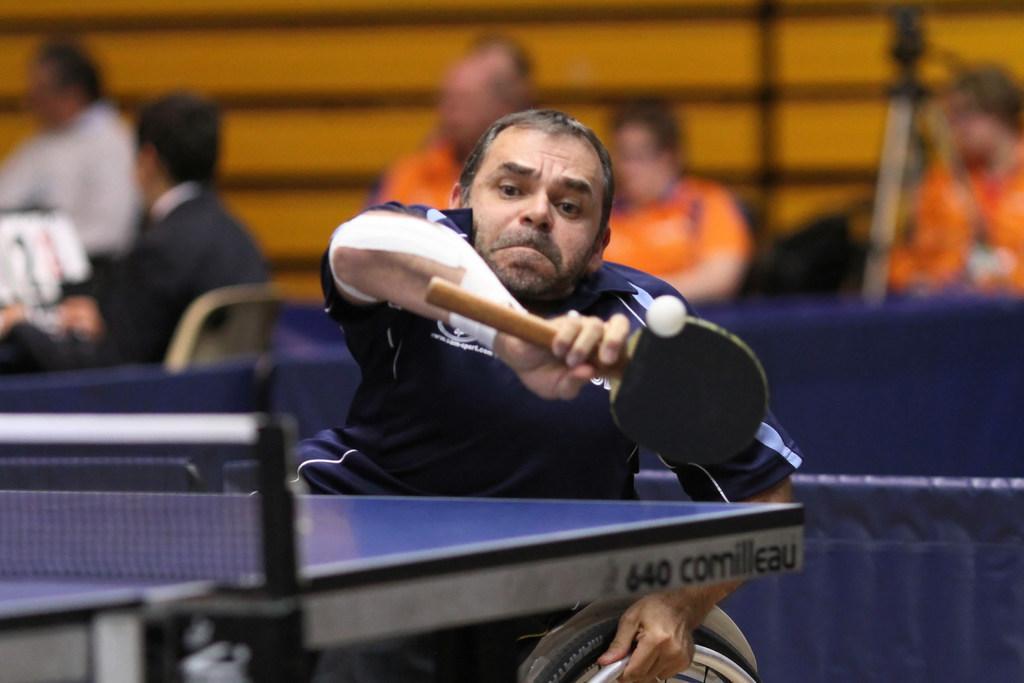In one or two sentences, can you explain what this image depicts? In this picture there is a person sitting on the wheel chair and playing the game and holding a bat. 